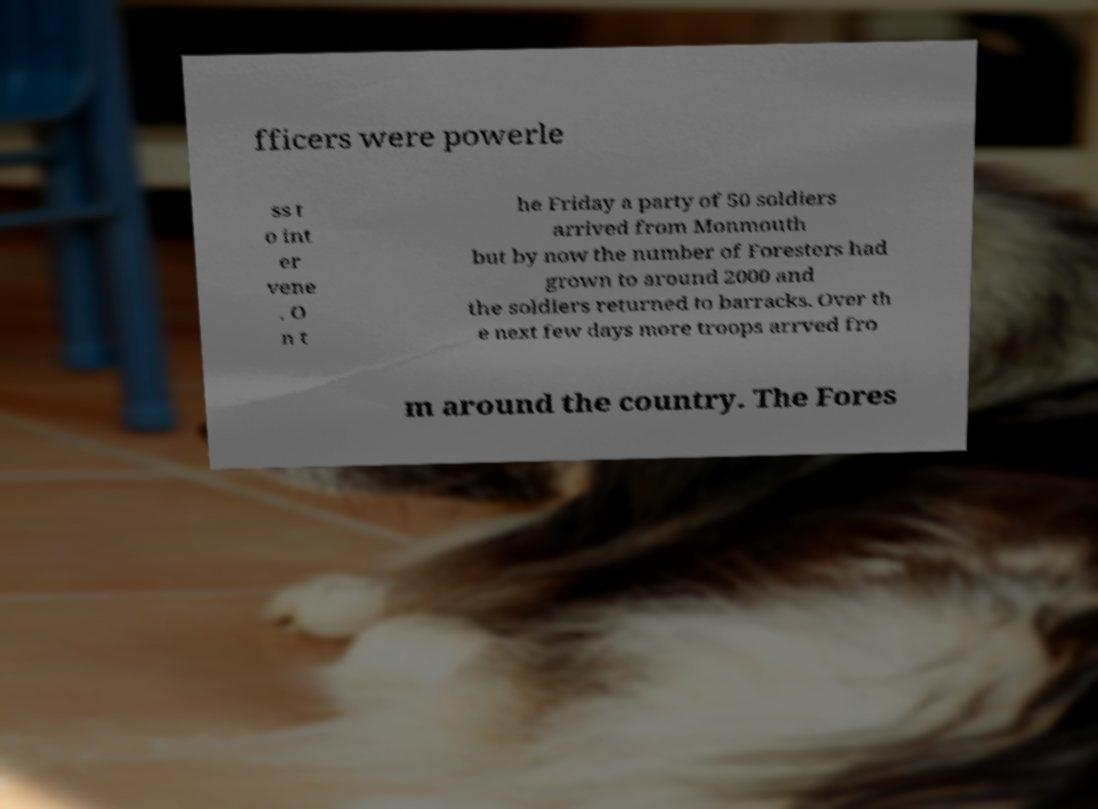Please read and relay the text visible in this image. What does it say? fficers were powerle ss t o int er vene . O n t he Friday a party of 50 soldiers arrived from Monmouth but by now the number of Foresters had grown to around 2000 and the soldiers returned to barracks. Over th e next few days more troops arrved fro m around the country. The Fores 